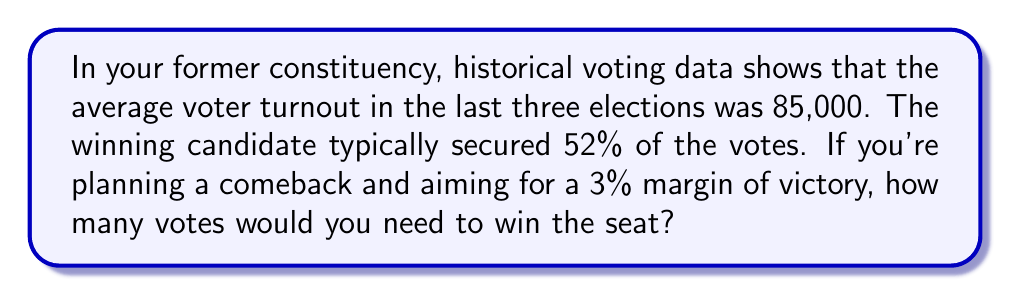Help me with this question. Let's approach this step-by-step:

1) First, we need to calculate the number of votes that represent 52% of the turnout:
   $$0.52 \times 85,000 = 44,200$$ votes

2) Now, we want to increase this by 3 percentage points to get a 3% margin of victory. So we're aiming for 55% of the vote:
   $$0.55 \times 85,000 = 46,750$$ votes

3) To double-check our margin:
   $$46,750 - 44,200 = 2,550$$ votes
   
   $$\frac{2,550}{85,000} \times 100 \approx 3\%$$

Therefore, to win the seat with a 3% margin, you would need 46,750 votes.
Answer: 46,750 votes 